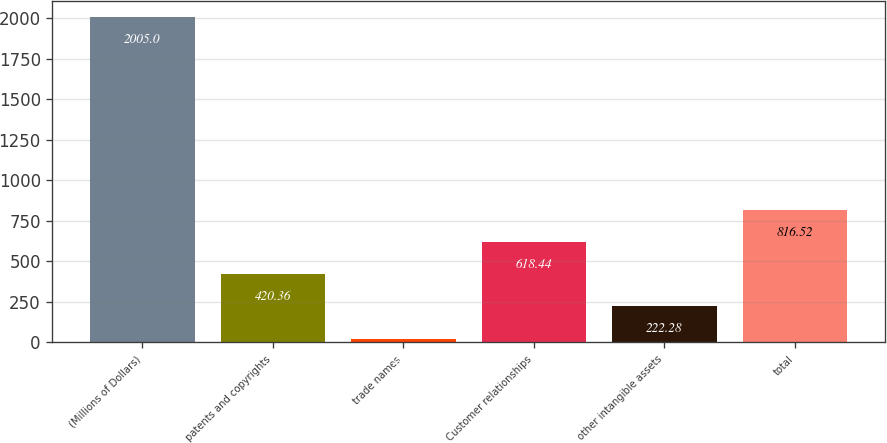Convert chart to OTSL. <chart><loc_0><loc_0><loc_500><loc_500><bar_chart><fcel>(Millions of Dollars)<fcel>patents and copyrights<fcel>trade names<fcel>Customer relationships<fcel>other intangible assets<fcel>total<nl><fcel>2005<fcel>420.36<fcel>24.2<fcel>618.44<fcel>222.28<fcel>816.52<nl></chart> 